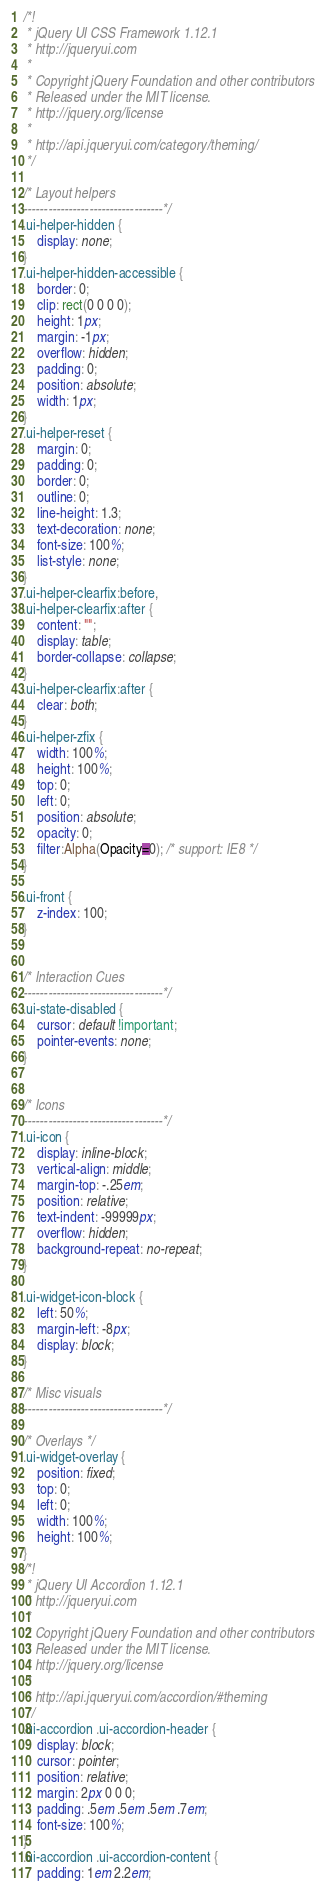<code> <loc_0><loc_0><loc_500><loc_500><_CSS_>/*!
 * jQuery UI CSS Framework 1.12.1
 * http://jqueryui.com
 *
 * Copyright jQuery Foundation and other contributors
 * Released under the MIT license.
 * http://jquery.org/license
 *
 * http://api.jqueryui.com/category/theming/
 */

/* Layout helpers
----------------------------------*/
.ui-helper-hidden {
	display: none;
}
.ui-helper-hidden-accessible {
	border: 0;
	clip: rect(0 0 0 0);
	height: 1px;
	margin: -1px;
	overflow: hidden;
	padding: 0;
	position: absolute;
	width: 1px;
}
.ui-helper-reset {
	margin: 0;
	padding: 0;
	border: 0;
	outline: 0;
	line-height: 1.3;
	text-decoration: none;
	font-size: 100%;
	list-style: none;
}
.ui-helper-clearfix:before,
.ui-helper-clearfix:after {
	content: "";
	display: table;
	border-collapse: collapse;
}
.ui-helper-clearfix:after {
	clear: both;
}
.ui-helper-zfix {
	width: 100%;
	height: 100%;
	top: 0;
	left: 0;
	position: absolute;
	opacity: 0;
	filter:Alpha(Opacity=0); /* support: IE8 */
}

.ui-front {
	z-index: 100;
}


/* Interaction Cues
----------------------------------*/
.ui-state-disabled {
	cursor: default !important;
	pointer-events: none;
}


/* Icons
----------------------------------*/
.ui-icon {
	display: inline-block;
	vertical-align: middle;
	margin-top: -.25em;
	position: relative;
	text-indent: -99999px;
	overflow: hidden;
	background-repeat: no-repeat;
}

.ui-widget-icon-block {
	left: 50%;
	margin-left: -8px;
	display: block;
}

/* Misc visuals
----------------------------------*/

/* Overlays */
.ui-widget-overlay {
	position: fixed;
	top: 0;
	left: 0;
	width: 100%;
	height: 100%;
}
/*!
 * jQuery UI Accordion 1.12.1
 * http://jqueryui.com
 *
 * Copyright jQuery Foundation and other contributors
 * Released under the MIT license.
 * http://jquery.org/license
 *
 * http://api.jqueryui.com/accordion/#theming
 */
.ui-accordion .ui-accordion-header {
	display: block;
	cursor: pointer;
	position: relative;
	margin: 2px 0 0 0;
	padding: .5em .5em .5em .7em;
	font-size: 100%;
}
.ui-accordion .ui-accordion-content {
	padding: 1em 2.2em;</code> 